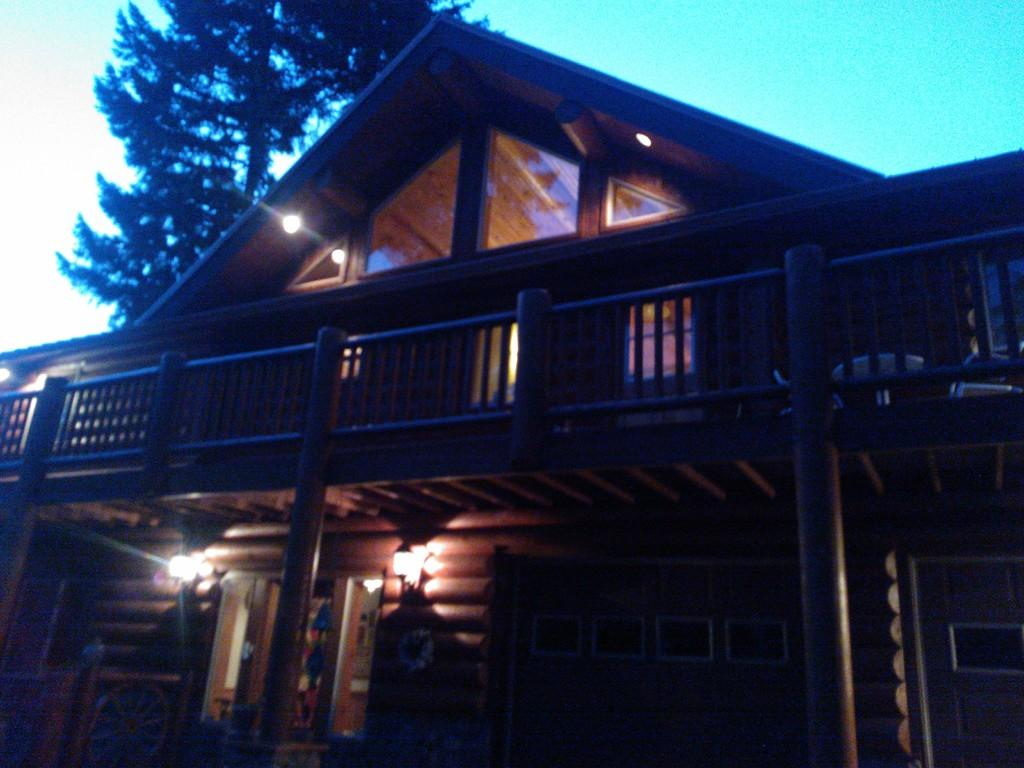What type of house is in the image? There is a wooden house in the image. What can be seen inside the house? The lights visible in the image suggest that there is some form of illumination inside the house. What is in the background of the image? There is a tree in the background of the image. What is visible above the house and tree? The sky is visible in the image. Where is the cushion placed in the image? There is no cushion present in the image. What type of bath can be seen in the image? There is no bath present in the image. 